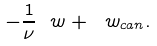<formula> <loc_0><loc_0><loc_500><loc_500>- \frac { 1 } { \nu } \ w + \ w _ { c a n } .</formula> 